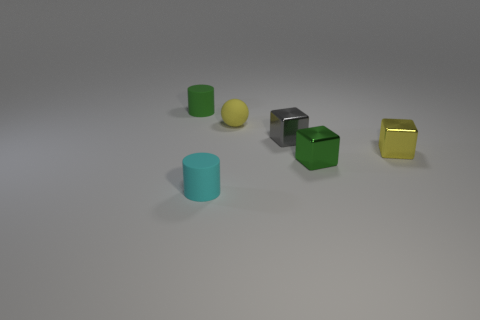There is a cube that is the same color as the ball; what is its material?
Your answer should be very brief. Metal. There is a cylinder behind the ball; is its color the same as the tiny sphere?
Provide a succinct answer. No. The cube on the left side of the green metal thing that is to the right of the tiny cylinder behind the tiny gray block is made of what material?
Provide a succinct answer. Metal. Are there any metallic things of the same color as the tiny matte ball?
Ensure brevity in your answer.  Yes. Are there fewer small things that are on the left side of the tiny green cube than small things?
Your response must be concise. Yes. What number of objects are behind the cyan cylinder and to the left of the small gray object?
Provide a succinct answer. 2. Is the number of spheres in front of the tiny yellow rubber sphere less than the number of small gray objects to the right of the tiny yellow metal object?
Your answer should be compact. No. Is the color of the tiny thing that is behind the yellow ball the same as the small metallic object in front of the small yellow metal thing?
Give a very brief answer. Yes. The object that is both left of the small yellow matte ball and behind the yellow shiny block is made of what material?
Make the answer very short. Rubber. Is there a gray block?
Provide a succinct answer. Yes. 